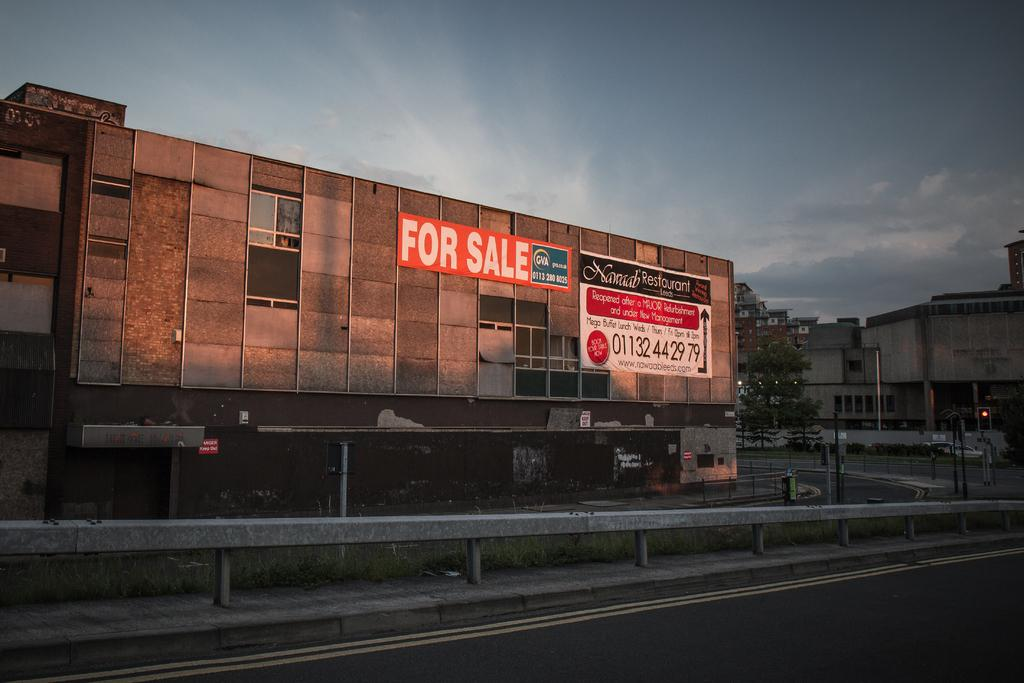What is the main feature of the image? There is a road in the image. What separates the lanes on the road? There is a divider on the road. What type of vegetation can be seen in the image? There is grass visible in the image. What structures are present in the image? There are buildings in the image. What other natural elements are present in the image? There are trees in the image. What is moving along the road in the image? There are vehicles on the road. What can be seen above the road in the image? The sky is visible in the image. What type of coal is being mined in the image? There is no coal mining activity present in the image. What kind of stone can be seen in the image? There is no stone visible in the image. 